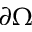Convert formula to latex. <formula><loc_0><loc_0><loc_500><loc_500>\partial \Omega</formula> 